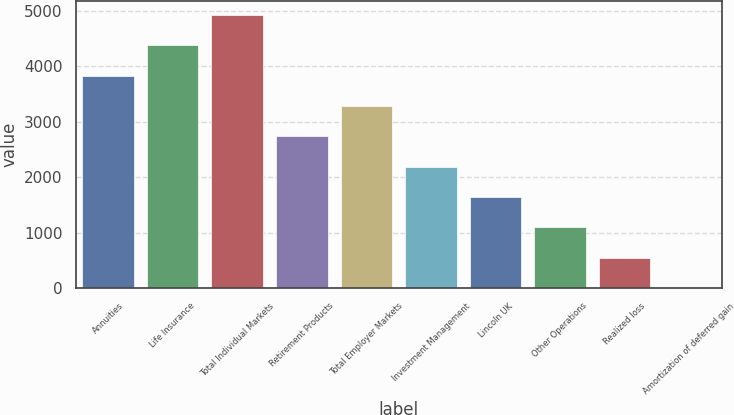Convert chart to OTSL. <chart><loc_0><loc_0><loc_500><loc_500><bar_chart><fcel>Annuities<fcel>Life Insurance<fcel>Total Individual Markets<fcel>Retirement Products<fcel>Total Employer Markets<fcel>Investment Management<fcel>Lincoln UK<fcel>Other Operations<fcel>Realized loss<fcel>Amortization of deferred gain<nl><fcel>3833.1<fcel>4380.4<fcel>4927.7<fcel>2738.5<fcel>3285.8<fcel>2191.2<fcel>1643.9<fcel>1096.6<fcel>549.3<fcel>2<nl></chart> 